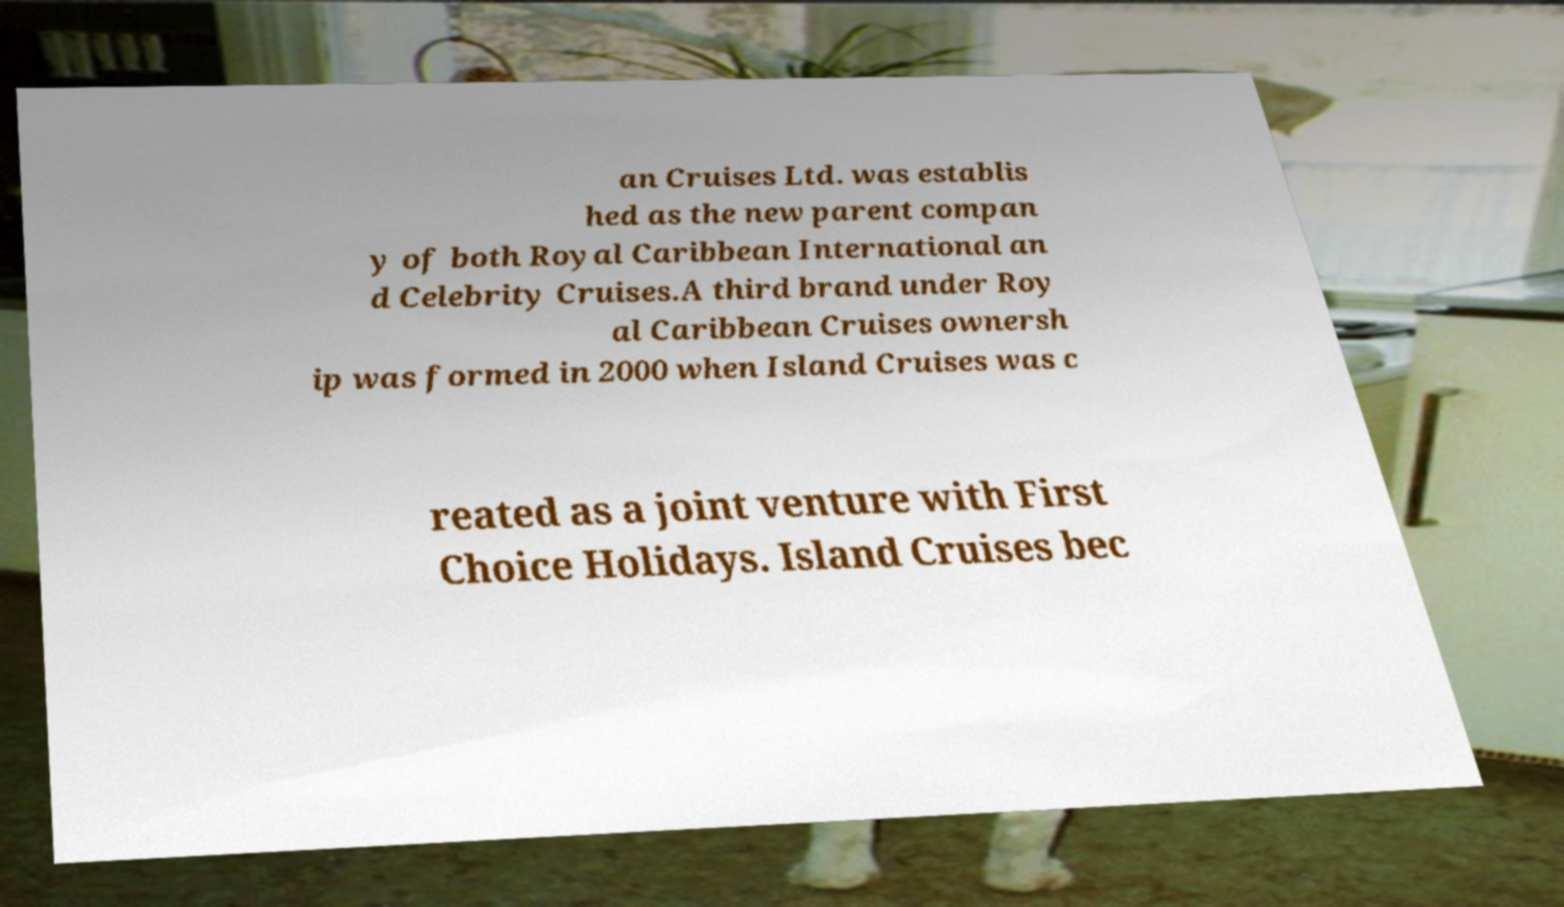Could you extract and type out the text from this image? an Cruises Ltd. was establis hed as the new parent compan y of both Royal Caribbean International an d Celebrity Cruises.A third brand under Roy al Caribbean Cruises ownersh ip was formed in 2000 when Island Cruises was c reated as a joint venture with First Choice Holidays. Island Cruises bec 